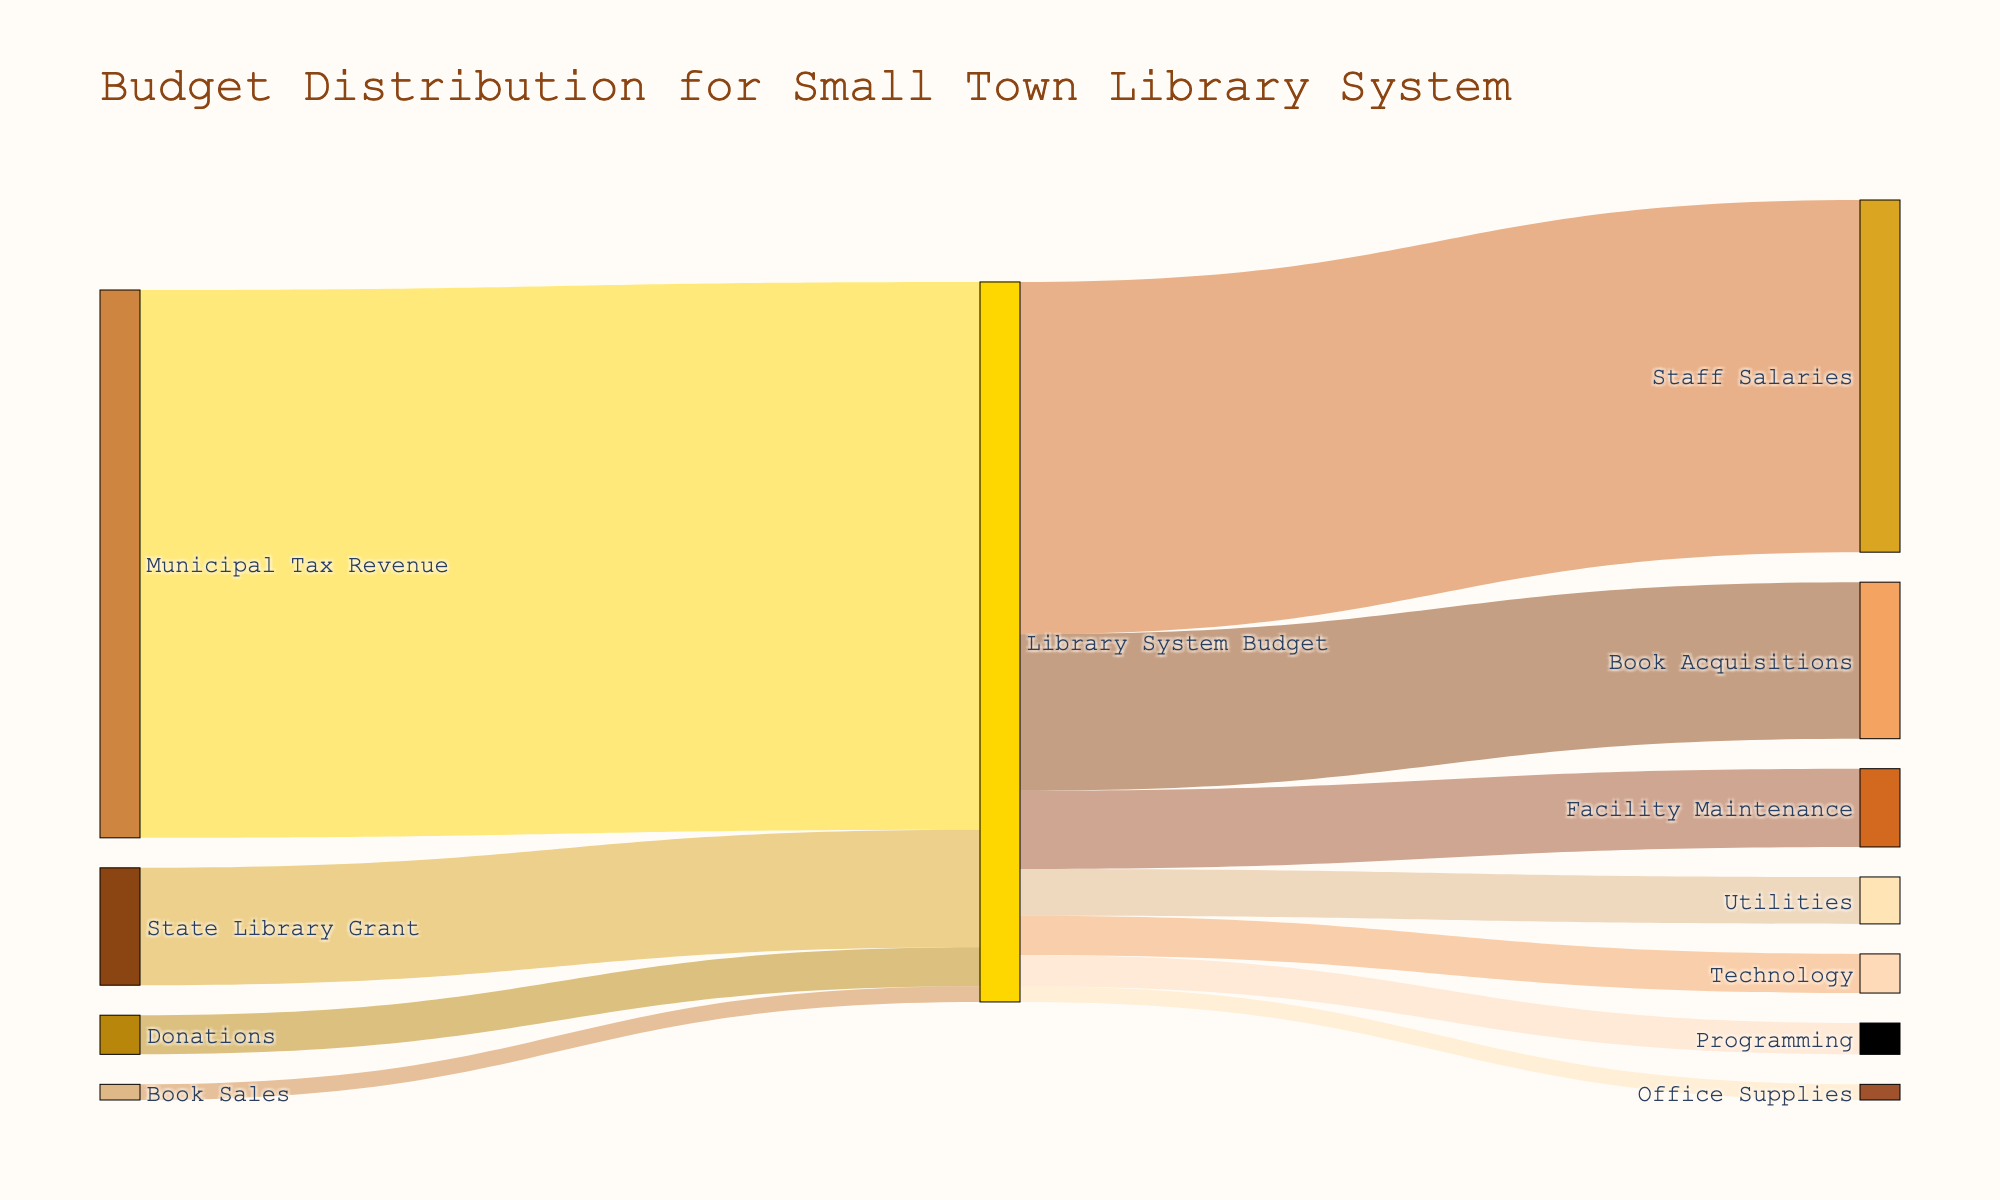What is the total budget for the small town library system? The total budget can be calculated by summing all the funding sources: 350,000 (Municipal Tax Revenue) + 75,000 (State Library Grant) + 25,000 (Donations) + 10,000 (Book Sales)
Answer: 460,000 Which funding source contributes the most to the library system budget? By comparing the contributions of Municipal Tax Revenue (350,000), State Library Grant (75,000), Donations (25,000), and Book Sales (10,000), the highest contribution comes from Municipal Tax Revenue.
Answer: Municipal Tax Revenue What percentage of the library system budget is allocated to Staff Salaries? The allocation to Staff Salaries is 225,000. The total budget is 460,000. Percentage = (225,000 / 460,000) * 100
Answer: 48.91% How much more is allocated to Staff Salaries compared to Book Acquisitions? Staff Salaries receive 225,000 and Book Acquisitions receive 100,000. The difference is 225,000 - 100,000
Answer: 125,000 Which categories receive the smallest portion of the budget? By checking the values, Office Supplies and Programming both receive 10,000 and 20,000 respectively, which are the smallest allocations.
Answer: Office Supplies How much of the library system budget is allocated to non-salary expenses? Non-salary expenses consist of Book Acquisitions (100,000), Facility Maintenance (50,000), Utilities (30,000), Technology (25,000), Programming (20,000), and Office Supplies (10,000). Summing these values: 100,000 + 50,000 + 30,000 + 25,000 + 20,000 + 10,000
Answer: 235,000 Is the amount allocated to Facility Maintenance greater than the amount from Book Sales? Facility Maintenance receives 50,000, while Book Sales contribute 10,000. Comparing these values, 50,000 is greater than 10,000.
Answer: Yes What is the combined allocation for Technology and Programming? Adding Technology (25,000) and Programming (20,000), the combined allocation is 25,000 + 20,000
Answer: 45,000 Which category has the highest expenditure in the library budget? By examining the expenditure values, the highest allocation is for Staff Salaries (225,000).
Answer: Staff Salaries What is the proportion of State Library Grant in the total funding? The State Library Grant contributes 75,000 to the total budget of 460,000. Proportion = 75,000 / 460,000
Answer: 0.163 or 16.3% 